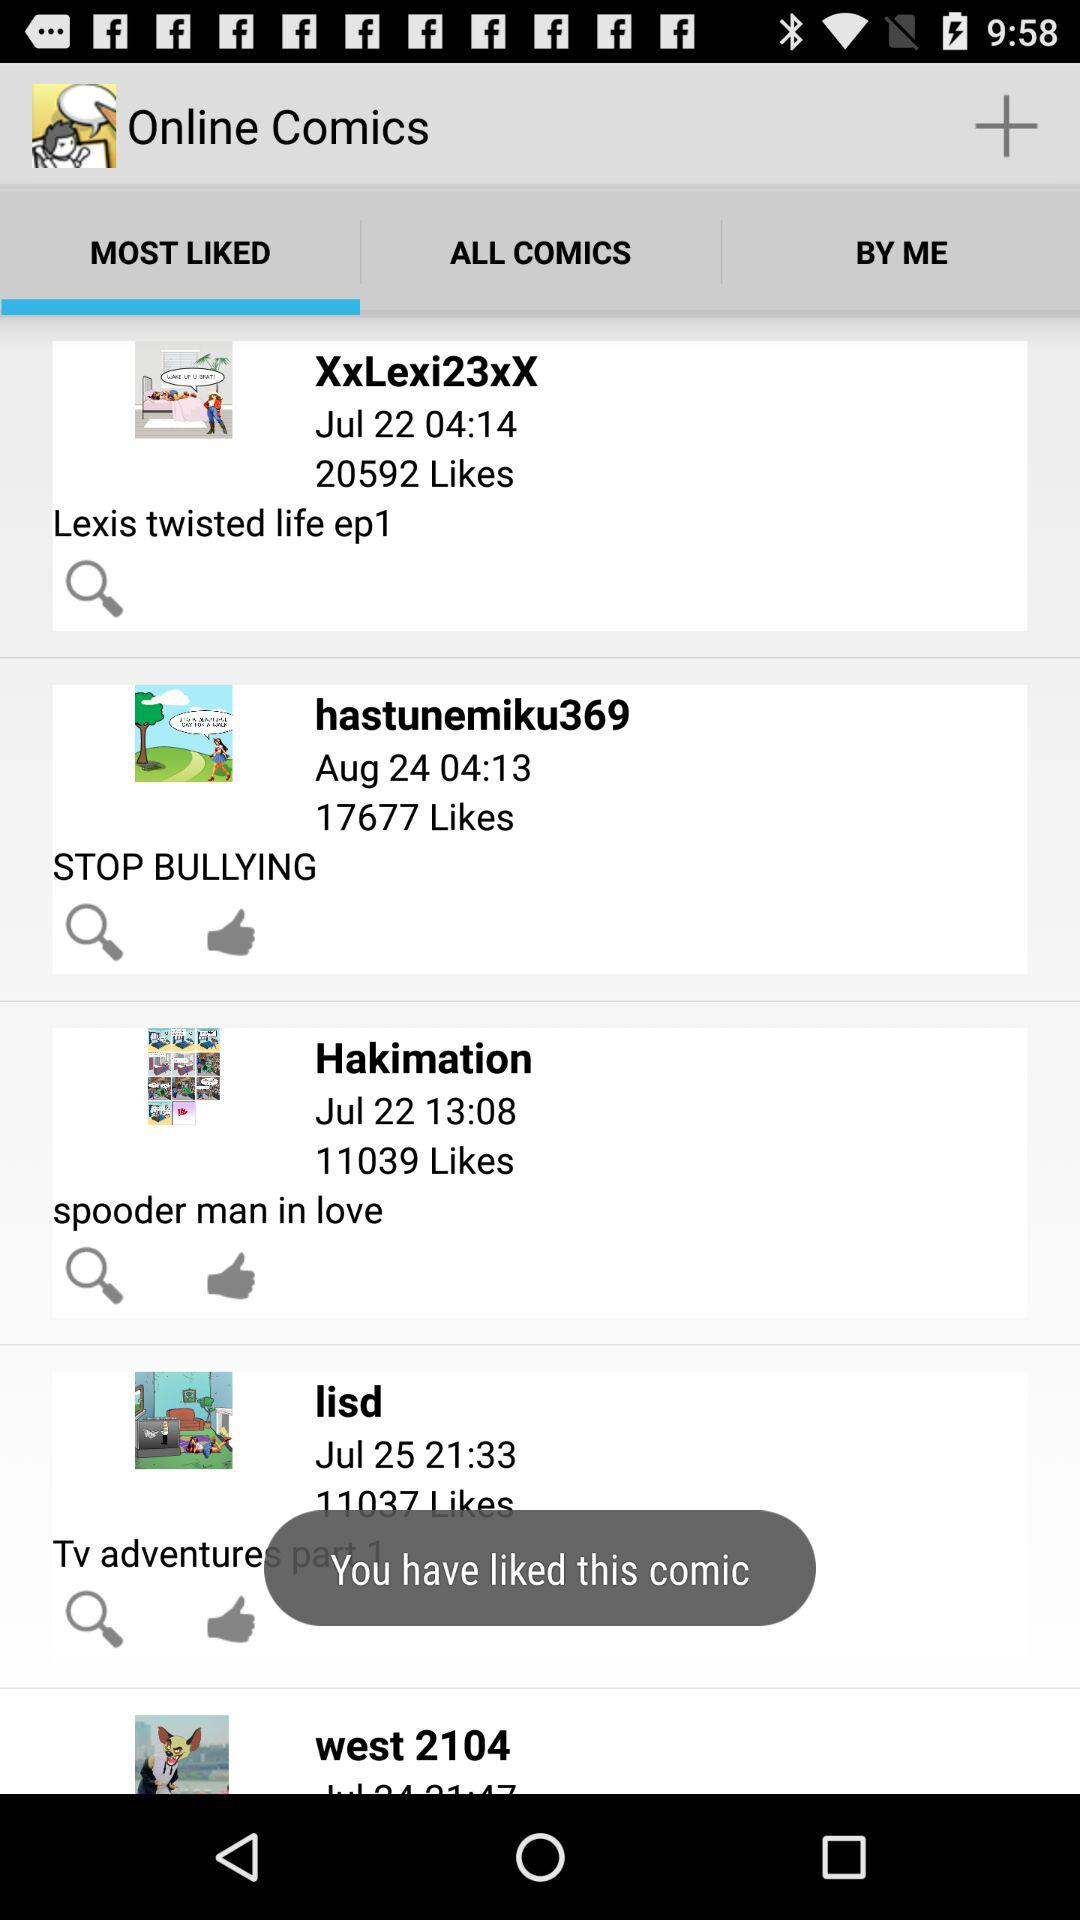What is the selected tab? The selected tab is "MOST LIKED". 